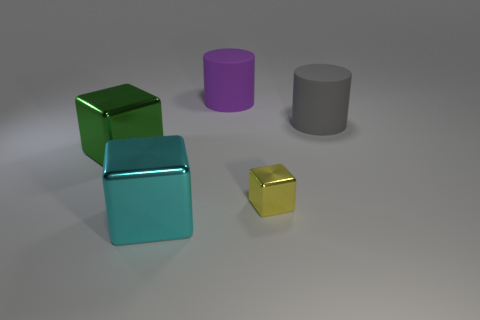Can you describe the shapes and colors of the objects seen here? Certainly! The image showcases a collection of geometric shapes including two cubes, one large and cyan and the other small and yellow, a purple cylinder, and a gray cylinder. The colors are solid and matte, except for the reflective cyan, which has a metallic sheen. 